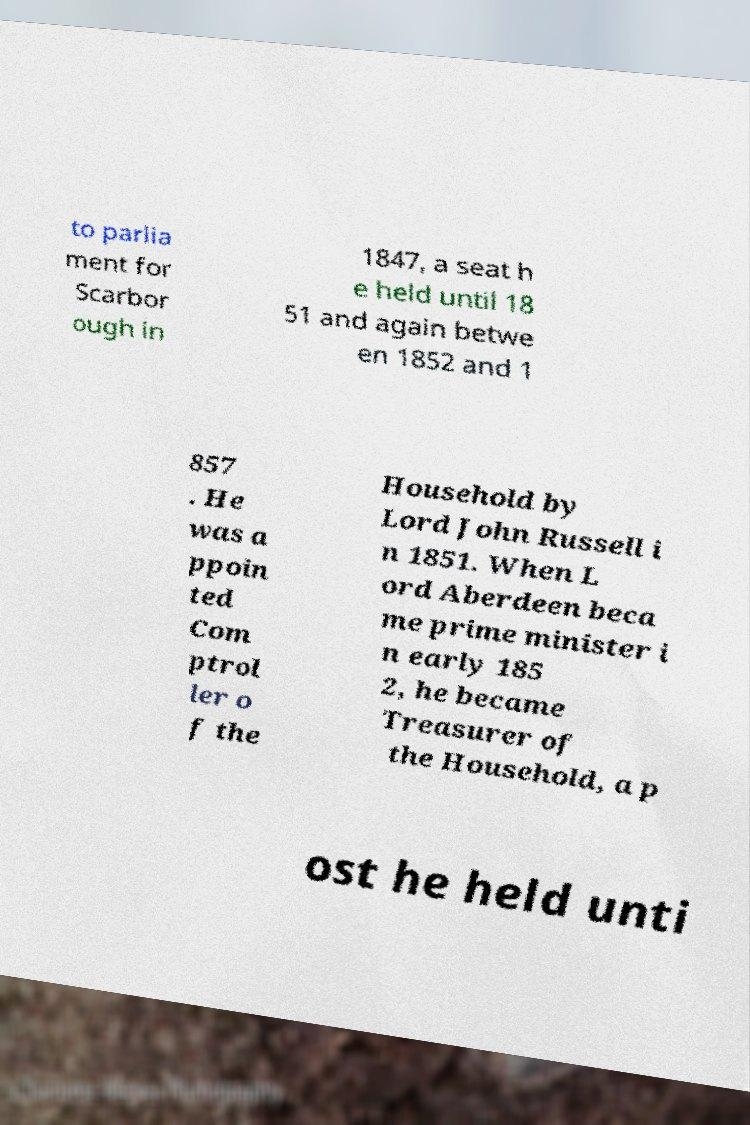Could you assist in decoding the text presented in this image and type it out clearly? to parlia ment for Scarbor ough in 1847, a seat h e held until 18 51 and again betwe en 1852 and 1 857 . He was a ppoin ted Com ptrol ler o f the Household by Lord John Russell i n 1851. When L ord Aberdeen beca me prime minister i n early 185 2, he became Treasurer of the Household, a p ost he held unti 